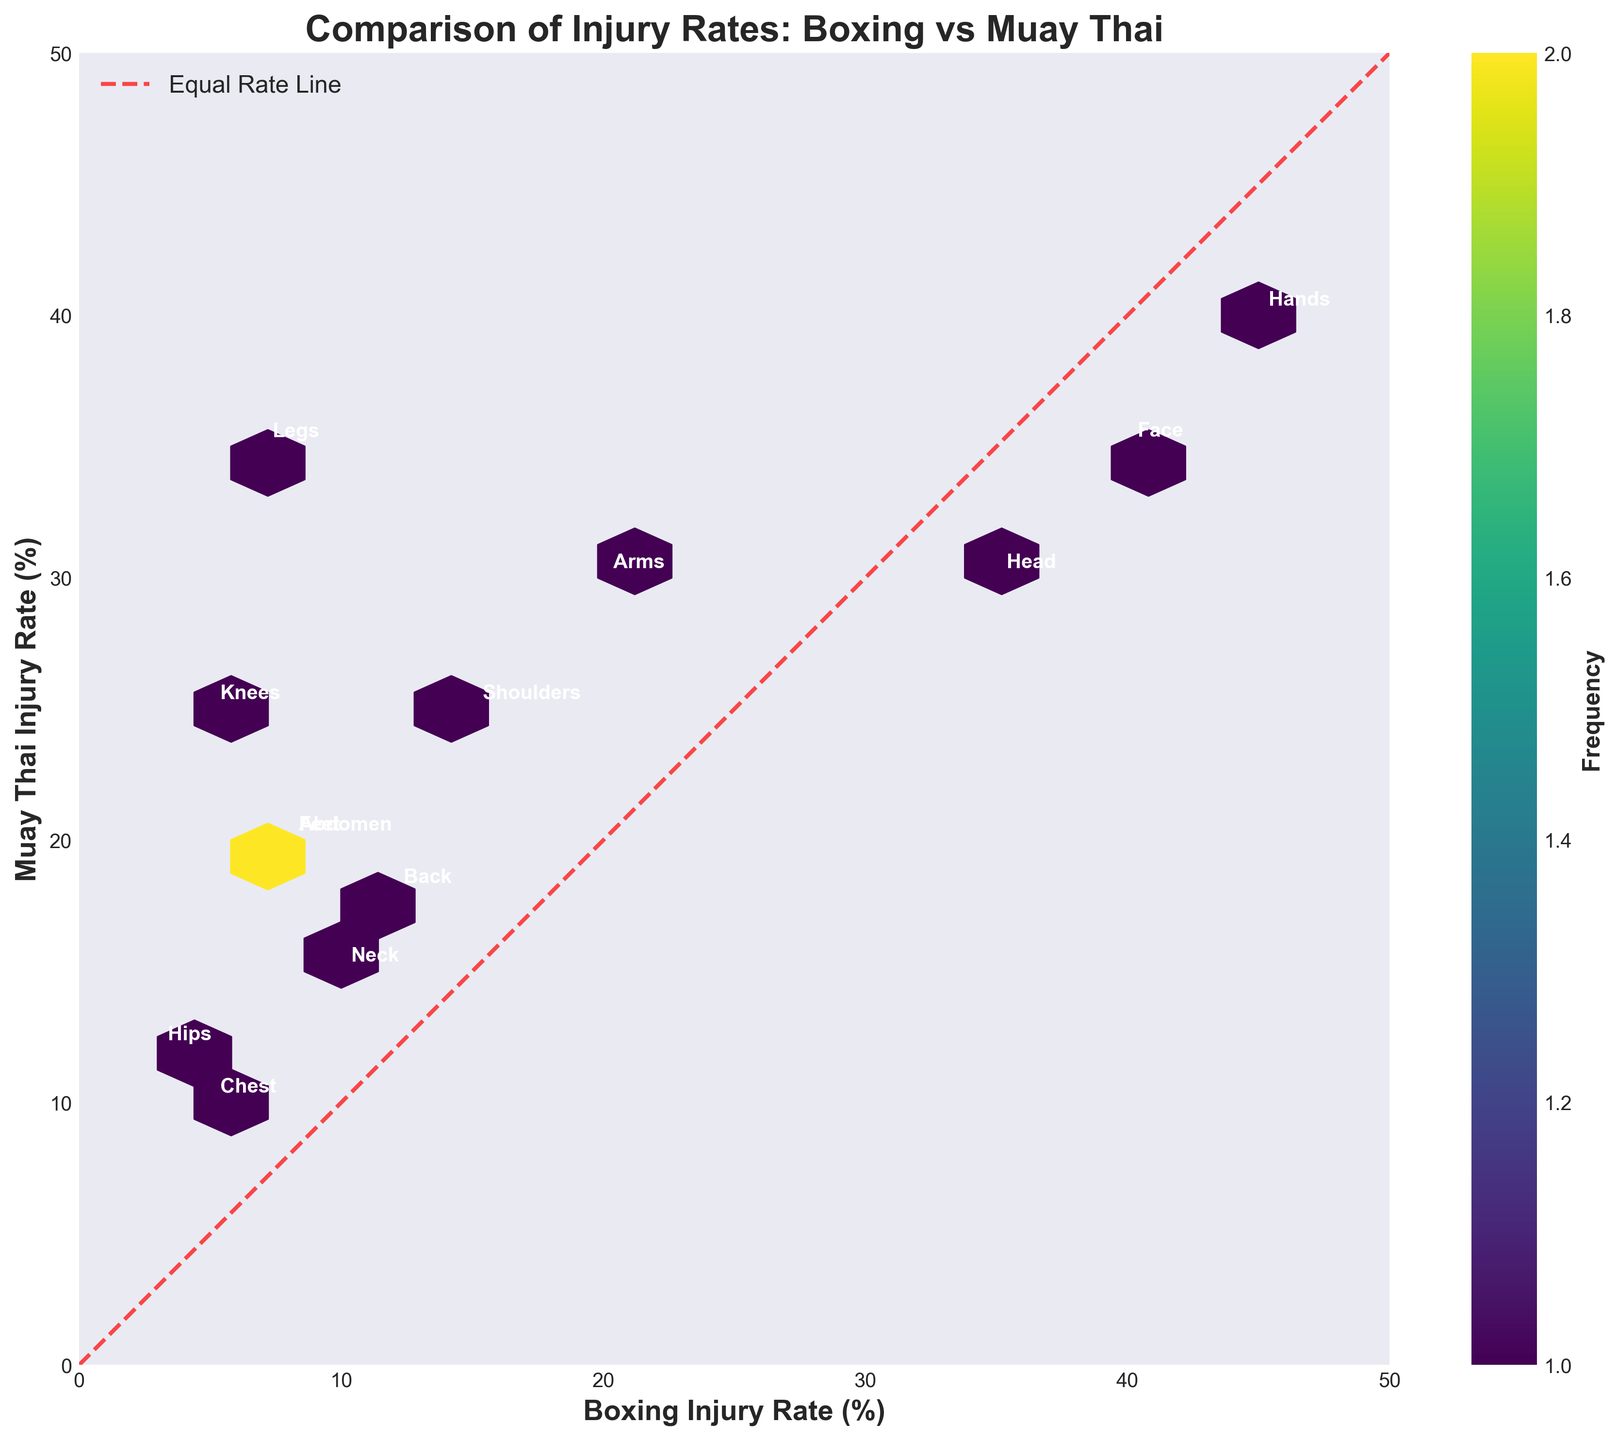What is the title of the figure? The title of the figure is positioned at the top center and is clearly labeled. We can directly read the title from this position.
Answer: Comparison of Injury Rates: Boxing vs Muay Thai What do the x and y axes represent? The x-axis represents the Boxing Injury Rate, while the y-axis represents the Muay Thai Injury Rate. This information is labeled next to each respective axis.
Answer: Boxing Injury Rate (%), Muay Thai Injury Rate (%) How many data points are in the hexbin plot? Since each body region listed in the data appears as a point in the plot, we simply count all the body regions provided in the data list. There are 13 body regions.
Answer: 13 Which injury rate is higher for the Hands, Boxing or Muay Thai? To determine this, look at the point labeled "Hands". Since it is situated on the hexbin plot, check its coordinates: 45 on the x-axis (Boxing) and 40 on the y-axis (Muay Thai). The point clearly shows a higher value for Boxing.
Answer: Boxing Are injury rates more evenly distributed between Boxing and Muay Thai for the Head or Legs? To answer this, we compare the locations of the points labeled "Head" and "Legs". The point for "Head" (35, 30) is closer to the equal rate line than that for "Legs" (7, 35), indicating more even distribution for "Head".
Answer: Head Which body region shows the largest difference in injury rates between Boxing and Muay Thai? To find the largest difference, check each point's proximity to the equal rate line. The point farthest from this line shows the largest difference. "Legs" at (7, 35) has a much greater spread compared to others.
Answer: Legs Does any body region have an equal injury rate in both sports? Observing whether any points lie exactly on the red dashed equal rate line answers this. The plot shows no such point falling directly on this line, indicating no region has equal rates.
Answer: No Which body region has the lowest Boxing injury rate compared to its Muay Thai injury rate? Look for the point with the smallest x-coordinate but a significantly larger y-coordinate. "Hips" is at (3, 12), showing the lowest Boxing rate (3%) with a considerably higher Muay Thai rate (12%).
Answer: Hips What is the general trend shown by the equal rate line? The equal rate line is a red dashed line extending from (0,0) to (50,50), indicating where Boxing and Muay Thai injury rates are equal. If points are close to this line, rates are similar; points further away show greater disparity.
Answer: Equal rates at line, disparity if away Which body region has the highest injury rate in Muay Thai compared to Boxing? Locate the point with the highest y-coordinate (Muay Thai) and cross-check with its label. The point at (7, 35) labeled "Legs" has the highest Muay Thai injury rate compared to Boxing (7% vs. 35%).
Answer: Legs 